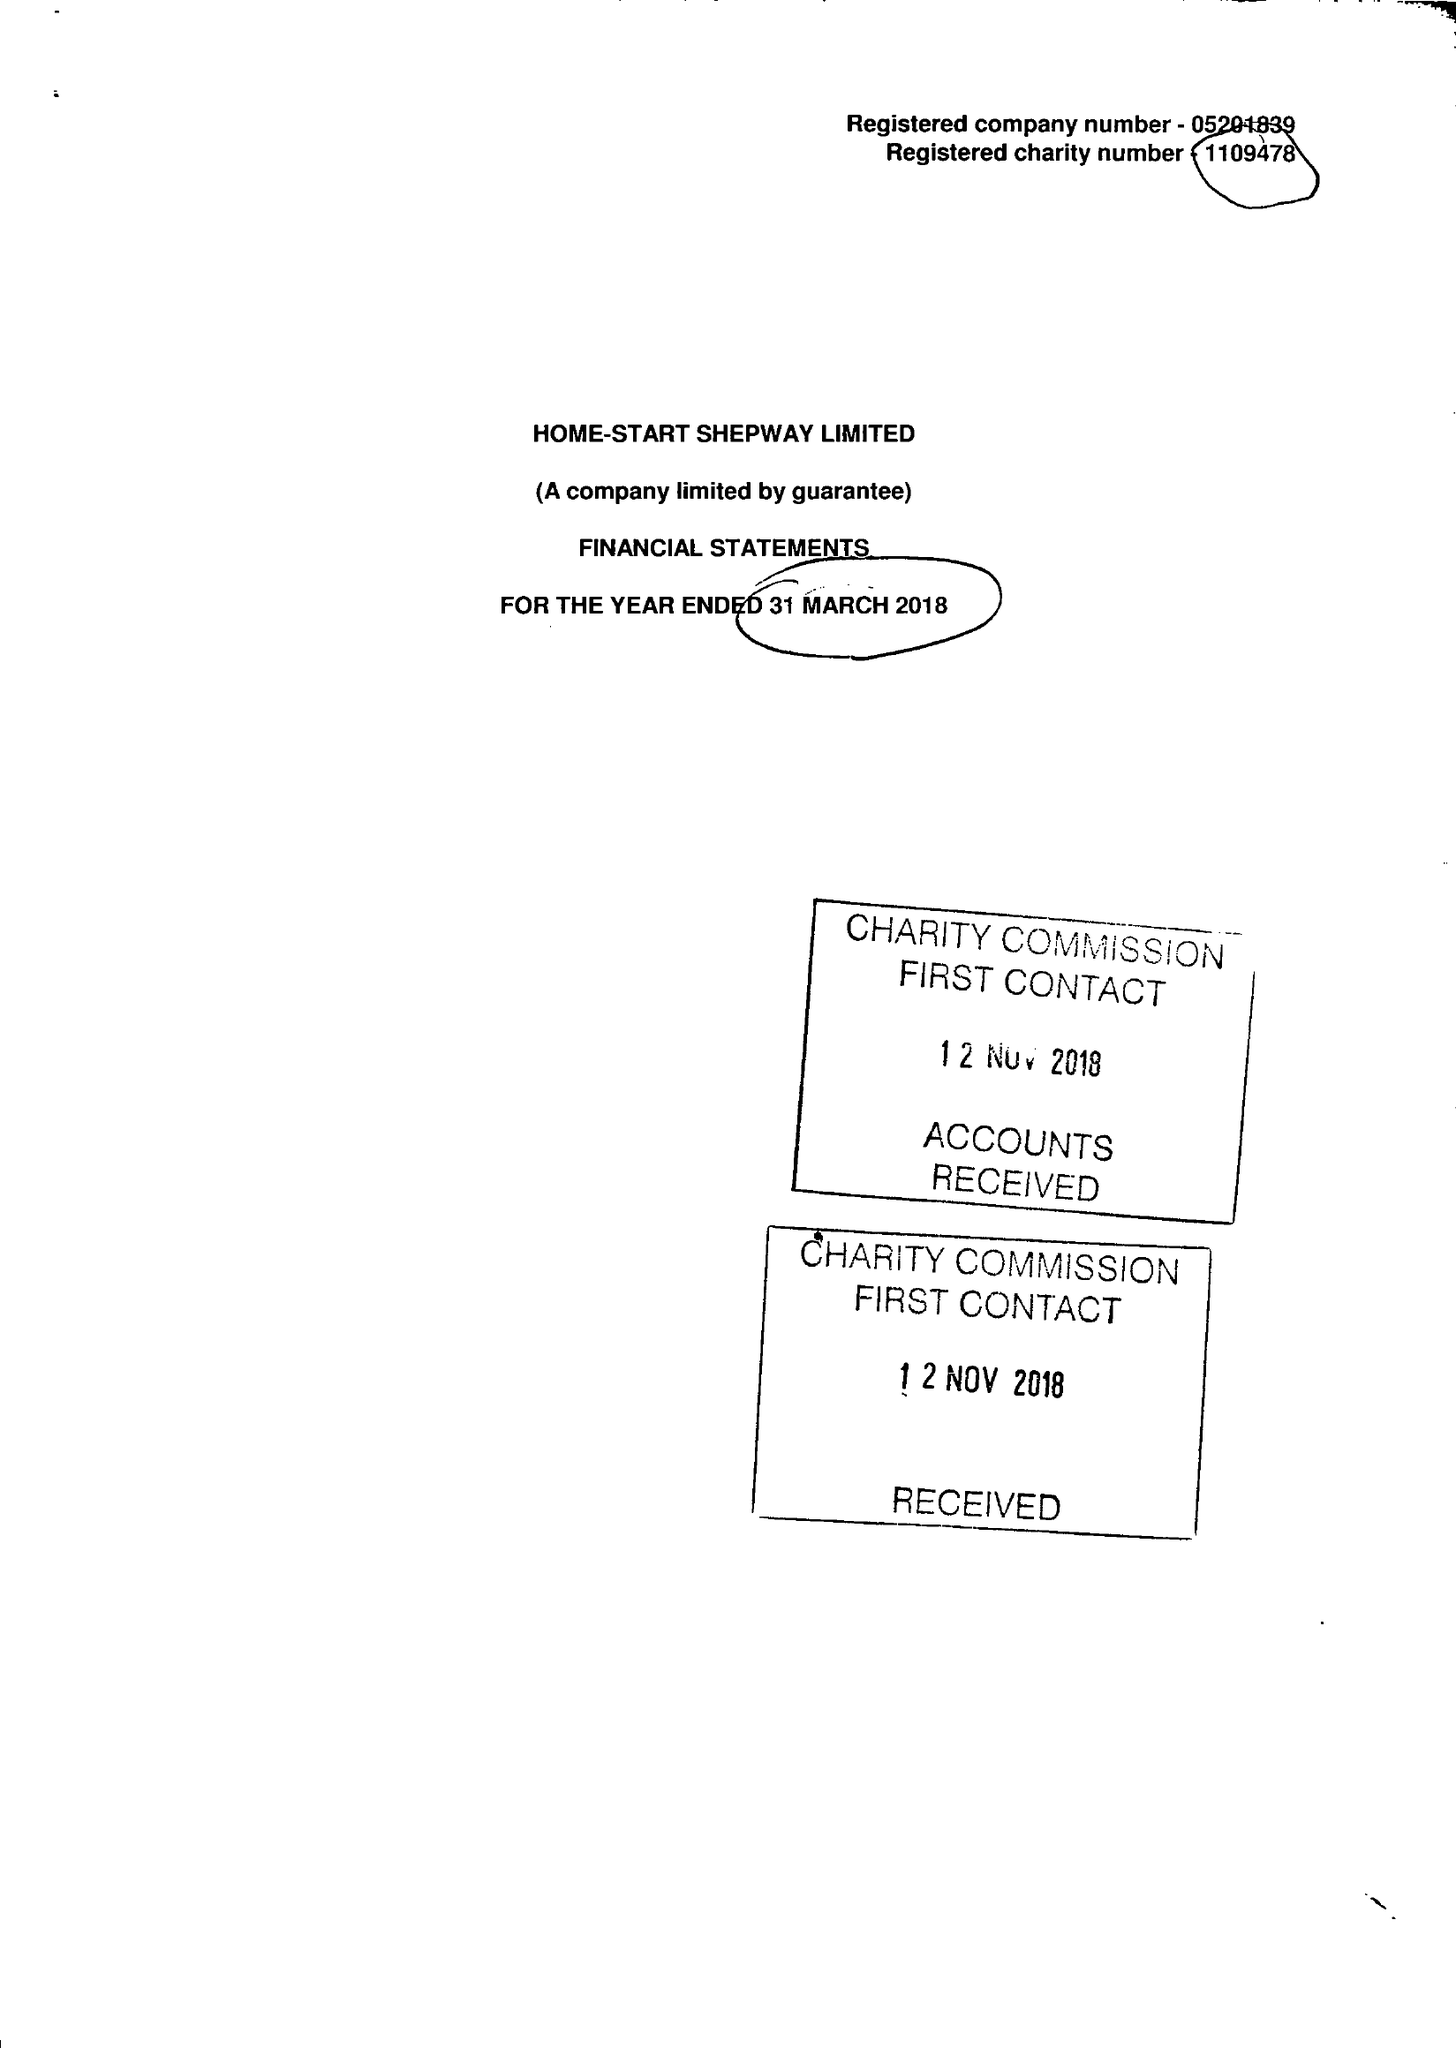What is the value for the address__street_line?
Answer the question using a single word or phrase. 24 CHERITON GARDENS 